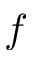Convert formula to latex. <formula><loc_0><loc_0><loc_500><loc_500>f</formula> 